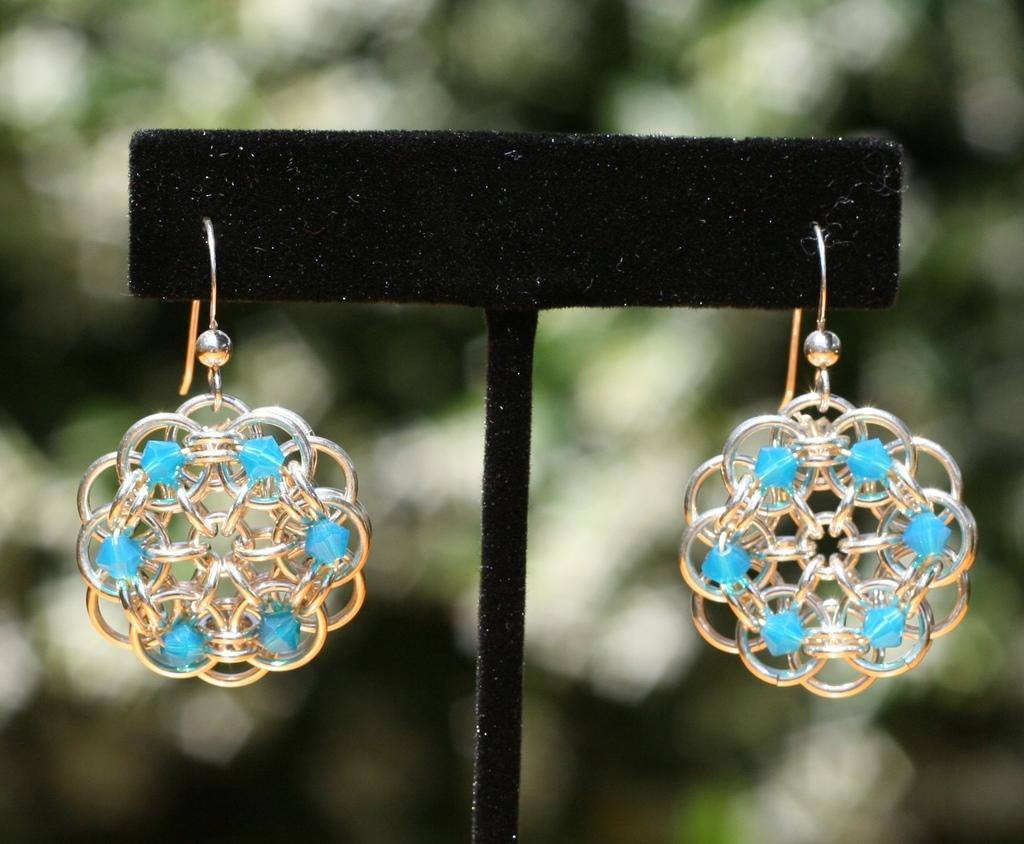What is the main object in the image? There is a small cardboard piece in the image. What is attached to the cardboard piece? There are earrings hanging on the cardboard. Can you describe the background of the image? The background of the image is blurry. What type of bucket can be seen in the image? There is no bucket present in the image. Is the cart visible in the image? There is no cart present in the image. Can you describe the beggar in the image? There is no beggar present in the image. 